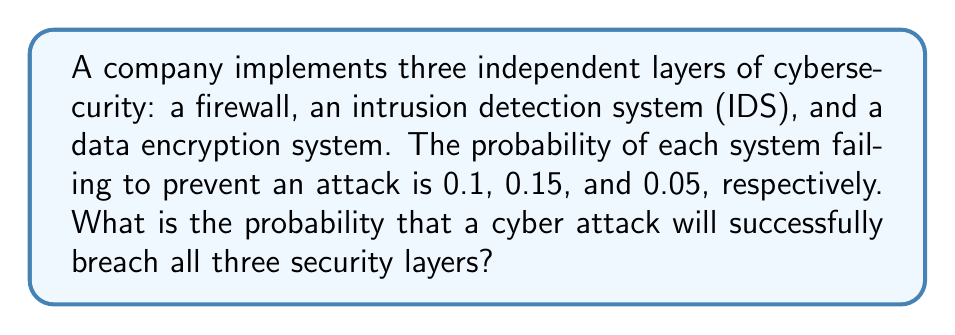Show me your answer to this math problem. To solve this problem, we need to follow these steps:

1. Understand that for a cyber attack to be successful, it must bypass all three security layers.

2. Since the security layers are independent, we can use the multiplication rule of probability.

3. The probability of success for each layer is the complement of the probability of failure:
   - Firewall: $1 - 0.1 = 0.9$
   - IDS: $1 - 0.15 = 0.85$
   - Encryption: $1 - 0.05 = 0.95$

4. Calculate the probability of a successful attack by multiplying the probabilities of breaching each layer:

   $$P(\text{successful attack}) = (1 - 0.9) \times (1 - 0.85) \times (1 - 0.95)$$

5. Simplify:
   $$P(\text{successful attack}) = 0.1 \times 0.15 \times 0.05$$

6. Calculate the final result:
   $$P(\text{successful attack}) = 0.00075 = 7.5 \times 10^{-4}$$

This means there is a 0.075% chance of a successful cyber attack breaching all three security layers.
Answer: $7.5 \times 10^{-4}$ or $0.00075$ or $0.075\%$ 